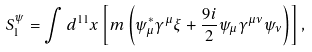Convert formula to latex. <formula><loc_0><loc_0><loc_500><loc_500>S _ { 1 } ^ { \psi } = \int d ^ { 1 1 } x \left [ m \left ( \psi _ { \mu } ^ { \ast } \gamma ^ { \mu } \xi + \frac { 9 i } { 2 } \psi _ { \mu } \gamma ^ { \mu \nu } \psi _ { \nu } \right ) \right ] ,</formula> 